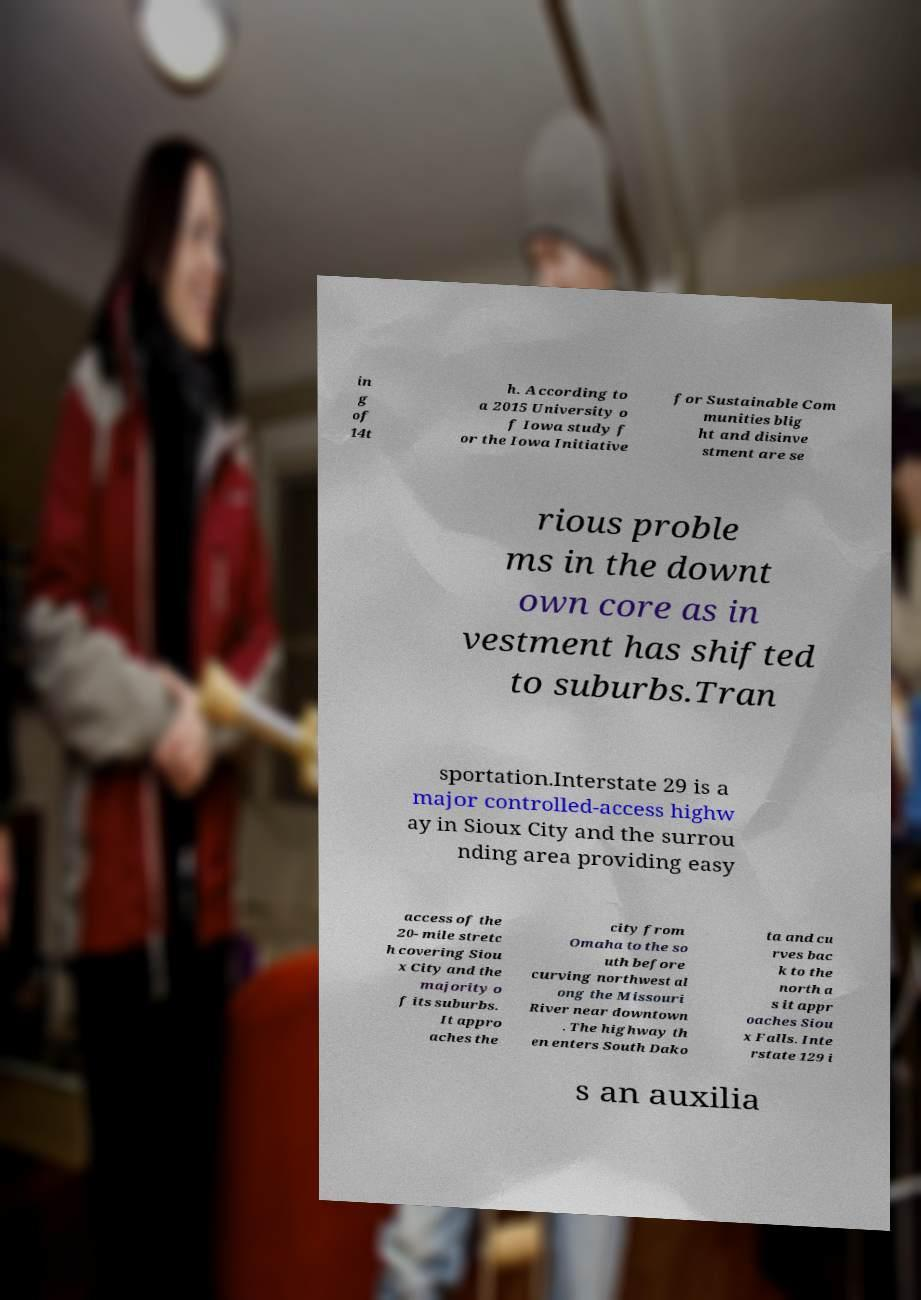Can you accurately transcribe the text from the provided image for me? in g of 14t h. According to a 2015 University o f Iowa study f or the Iowa Initiative for Sustainable Com munities blig ht and disinve stment are se rious proble ms in the downt own core as in vestment has shifted to suburbs.Tran sportation.Interstate 29 is a major controlled-access highw ay in Sioux City and the surrou nding area providing easy access of the 20- mile stretc h covering Siou x City and the majority o f its suburbs. It appro aches the city from Omaha to the so uth before curving northwest al ong the Missouri River near downtown . The highway th en enters South Dako ta and cu rves bac k to the north a s it appr oaches Siou x Falls. Inte rstate 129 i s an auxilia 